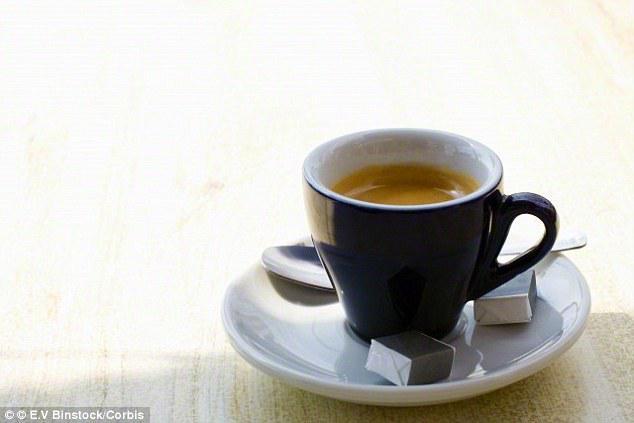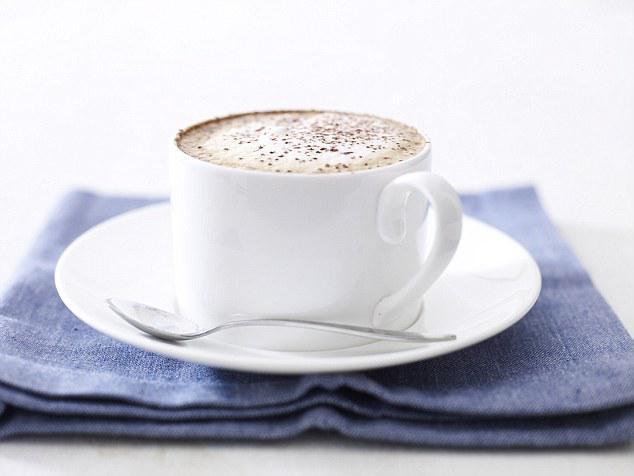The first image is the image on the left, the second image is the image on the right. Analyze the images presented: Is the assertion "There are two saucers in total, each holding a coffee cup." valid? Answer yes or no. Yes. The first image is the image on the left, the second image is the image on the right. Evaluate the accuracy of this statement regarding the images: "An image shows one light-colored cup on top of a matching saucer.". Is it true? Answer yes or no. Yes. 